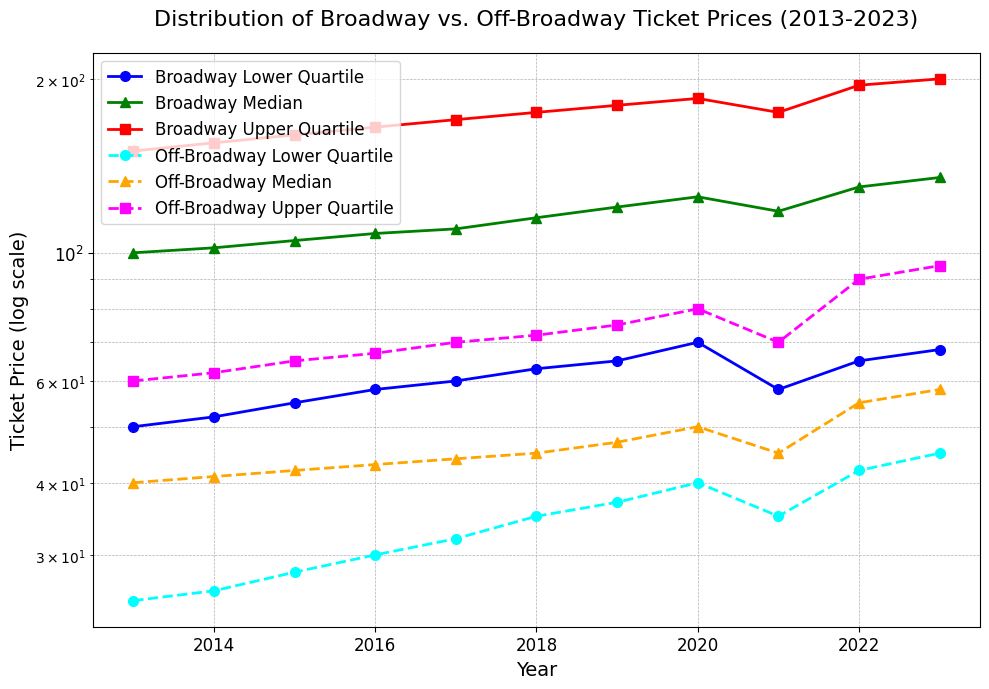Which type of theater had the higher median ticket price in 2017? To determine this, look at the green line for Broadway and the orange line for Off-Broadway in 2017. The Broadway median is at 110, while Off-Broadway shows a median of 44.
Answer: Broadway How did the median ticket price for Broadway change from 2013 to 2023? Check the green line for Broadway in 2013 and 2023. It increased from 100 to 135.
Answer: Increased by 35 In which year was the difference between the upper quartile ticket prices of Broadway and Off-Broadway the greatest? Compare the vertical distance between the red line (Broadway Upper Quartile) and the magenta line (Off-Broadway Upper Quartile) each year. The greatest difference is in 2023.
Answer: 2023 What is the ratio of the median ticket price of Broadway to Off-Broadway in 2020? Divide the Broadway median in 2020 by the Off-Broadway median in 2020. This is 125 divided by 50.
Answer: 2.5 Which year saw the most significant increase in the median ticket price for Off-Broadway shows? Observe the changes year over year for the orange line. From 2021 to 2022, the value increased from 45 to 55, which is a 10-unit increase.
Answer: 2022 Did any years show a decrease in Broadway median ticket prices? Look at the green line for Broadway median prices. From 2020 to 2021, it decreased from 125 to 118.
Answer: Yes, 2020 to 2021 What is the general trend for the lower quartile ticket prices of Off-Broadway shows from 2013 to 2023? Assess the cyan line from 2013 to 2023. It shows an increasing trend from 25 to 45.
Answer: Increasing In 2018, how much higher is the upper quartile ticket price of Broadway than that of Off-Broadway? Subtract the magenta line (Off-Broadway) from the red line (Broadway) for 2018. This is 175 - 72.
Answer: 103 By how much did the lower quartile ticket price for Broadway increase from its lowest point to its highest point in the decade? Find the difference between the minimum and maximum values on the blue line. This is from 50 in 2013 to 70 in 2020.
Answer: 20 